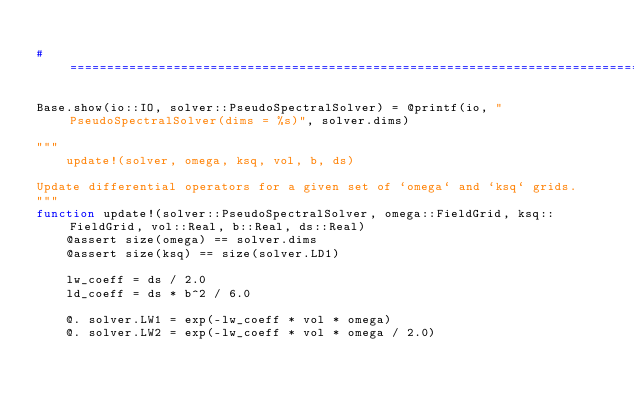<code> <loc_0><loc_0><loc_500><loc_500><_Julia_>
#==============================================================================#

Base.show(io::IO, solver::PseudoSpectralSolver) = @printf(io, "PseudoSpectralSolver(dims = %s)", solver.dims)

"""
	update!(solver, omega, ksq, vol, b, ds)

Update differential operators for a given set of `omega` and `ksq` grids.
"""
function update!(solver::PseudoSpectralSolver, omega::FieldGrid, ksq::FieldGrid, vol::Real, b::Real, ds::Real)
	@assert size(omega) == solver.dims
	@assert size(ksq) == size(solver.LD1)

	lw_coeff = ds / 2.0
	ld_coeff = ds * b^2 / 6.0

	@. solver.LW1 = exp(-lw_coeff * vol * omega)
	@. solver.LW2 = exp(-lw_coeff * vol * omega / 2.0)
</code> 